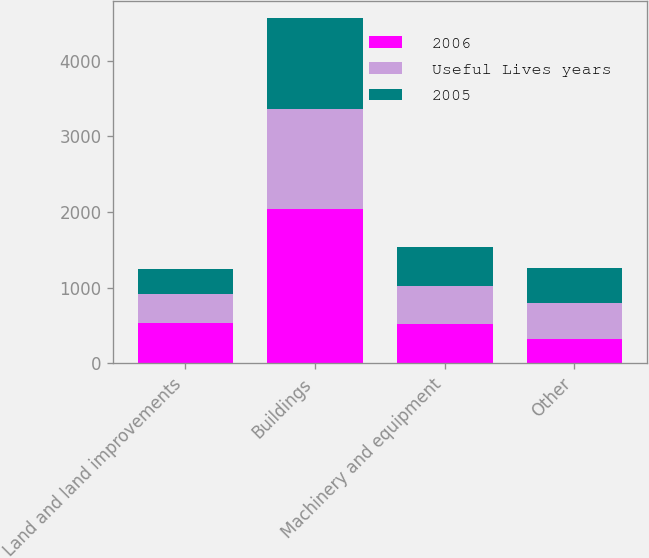<chart> <loc_0><loc_0><loc_500><loc_500><stacked_bar_chart><ecel><fcel>Land and land improvements<fcel>Buildings<fcel>Machinery and equipment<fcel>Other<nl><fcel>2006<fcel>530<fcel>2040<fcel>525<fcel>320<nl><fcel>Useful Lives years<fcel>385<fcel>1322<fcel>504<fcel>483<nl><fcel>2005<fcel>333<fcel>1201<fcel>504<fcel>452<nl></chart> 